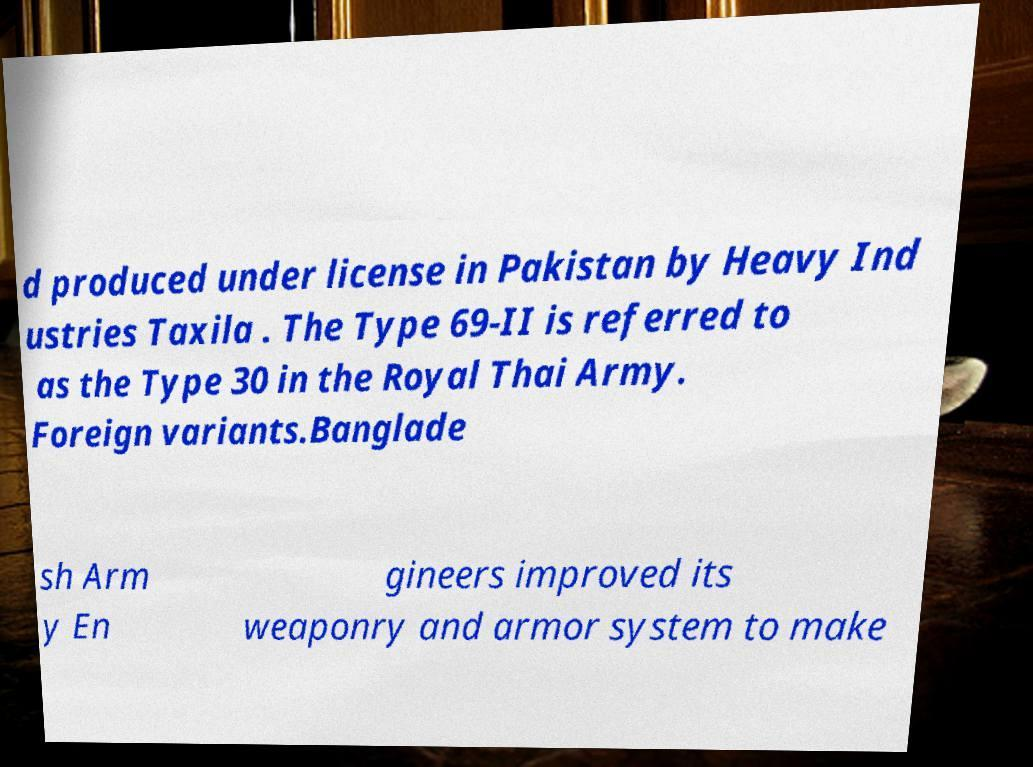Can you read and provide the text displayed in the image?This photo seems to have some interesting text. Can you extract and type it out for me? d produced under license in Pakistan by Heavy Ind ustries Taxila . The Type 69-II is referred to as the Type 30 in the Royal Thai Army. Foreign variants.Banglade sh Arm y En gineers improved its weaponry and armor system to make 